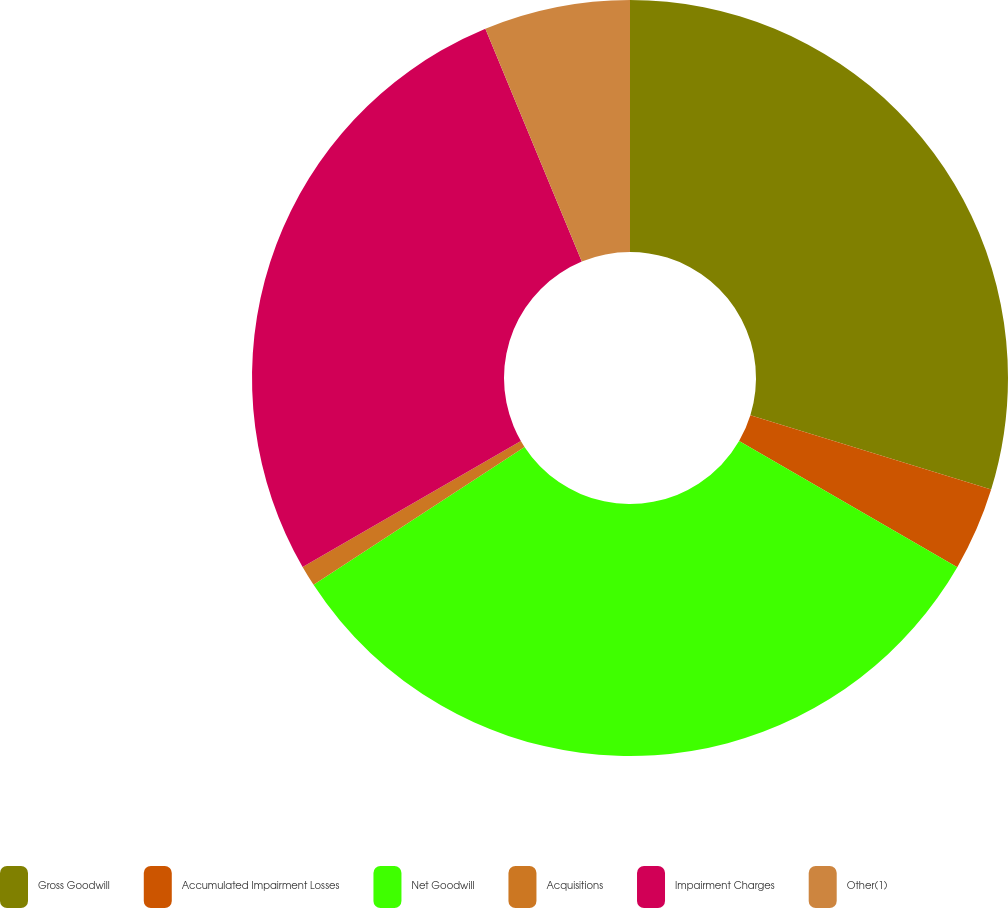Convert chart. <chart><loc_0><loc_0><loc_500><loc_500><pie_chart><fcel>Gross Goodwill<fcel>Accumulated Impairment Losses<fcel>Net Goodwill<fcel>Acquisitions<fcel>Impairment Charges<fcel>Other(1)<nl><fcel>29.77%<fcel>3.57%<fcel>32.45%<fcel>0.88%<fcel>27.08%<fcel>6.25%<nl></chart> 